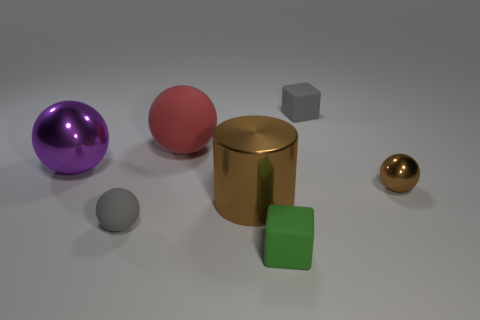Subtract 1 balls. How many balls are left? 3 Subtract all cyan cubes. Subtract all green cylinders. How many cubes are left? 2 Add 2 tiny gray matte cylinders. How many objects exist? 9 Subtract all cylinders. How many objects are left? 6 Subtract all small gray blocks. Subtract all large rubber cylinders. How many objects are left? 6 Add 6 small brown shiny balls. How many small brown shiny balls are left? 7 Add 2 purple spheres. How many purple spheres exist? 3 Subtract 1 red spheres. How many objects are left? 6 